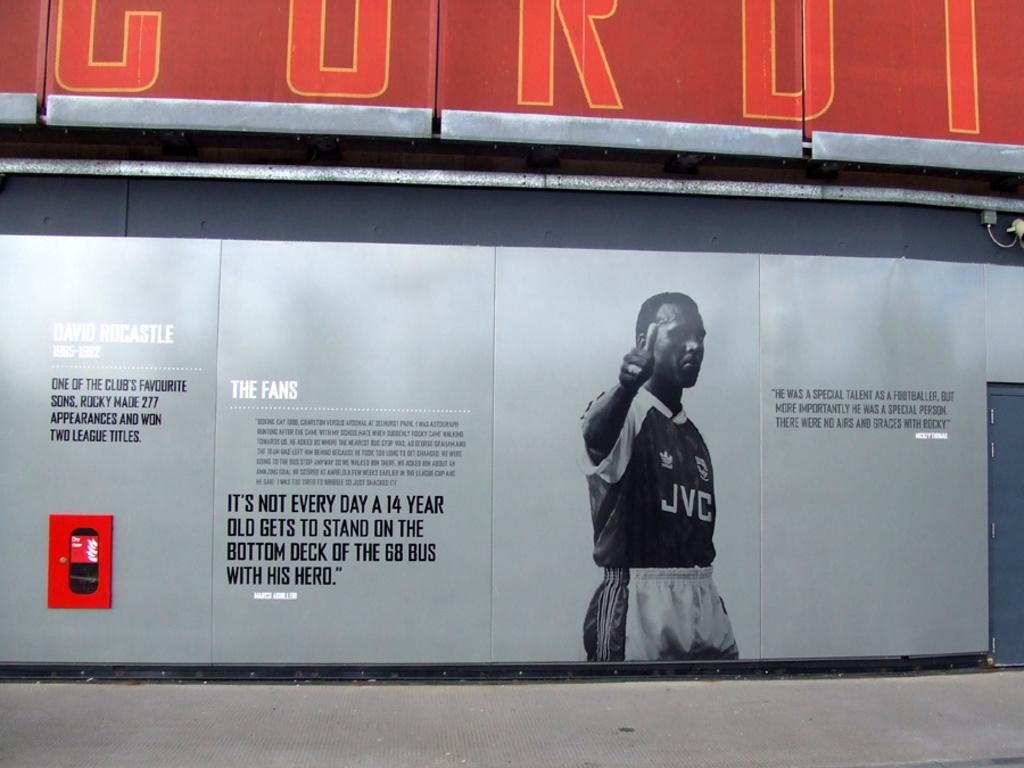<image>
Offer a succinct explanation of the picture presented. Man that is presented on a wall billboard, with the name David Rocastle 1985-1992. 